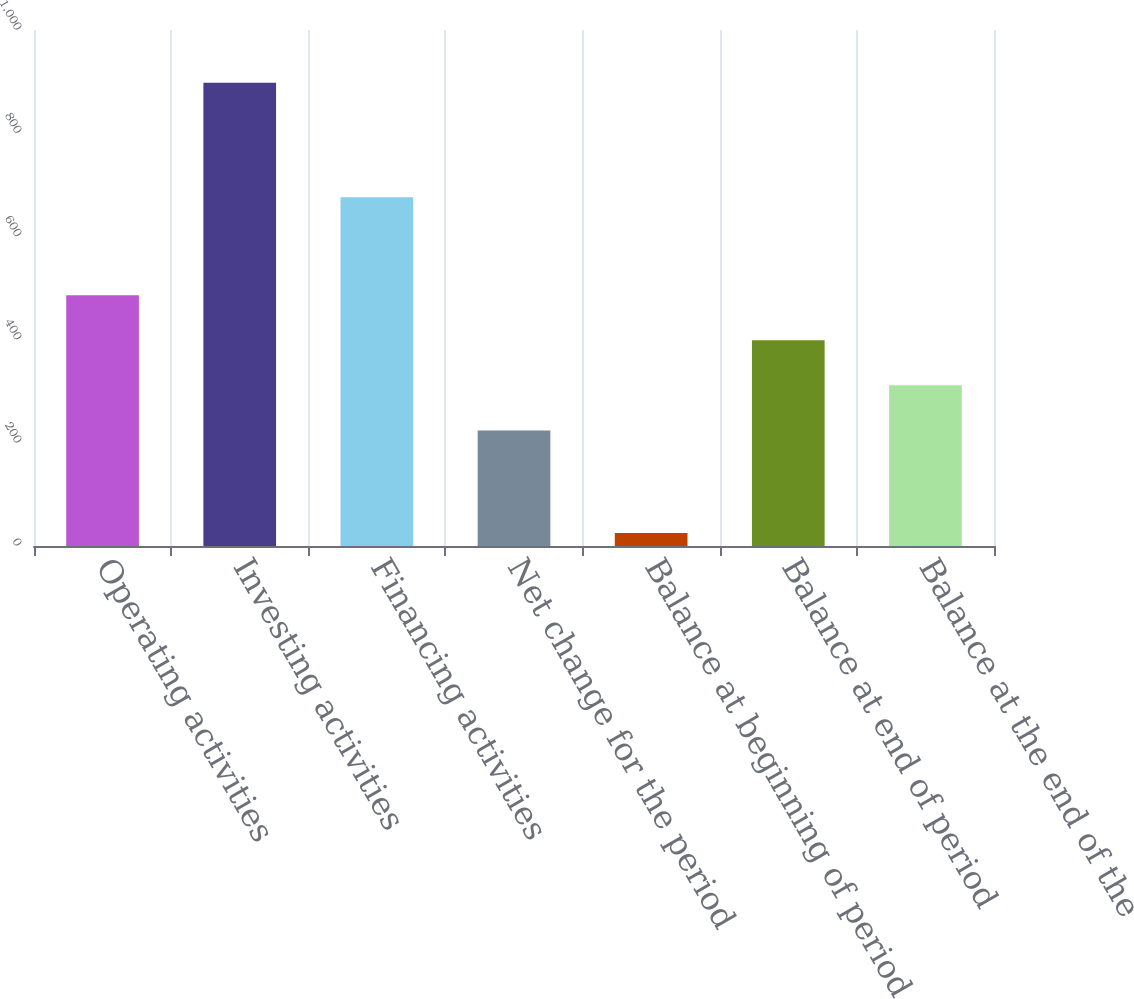Convert chart to OTSL. <chart><loc_0><loc_0><loc_500><loc_500><bar_chart><fcel>Operating activities<fcel>Investing activities<fcel>Financing activities<fcel>Net change for the period<fcel>Balance at beginning of period<fcel>Balance at end of period<fcel>Balance at the end of the<nl><fcel>485.9<fcel>898<fcel>676<fcel>224<fcel>25<fcel>398.6<fcel>311.3<nl></chart> 